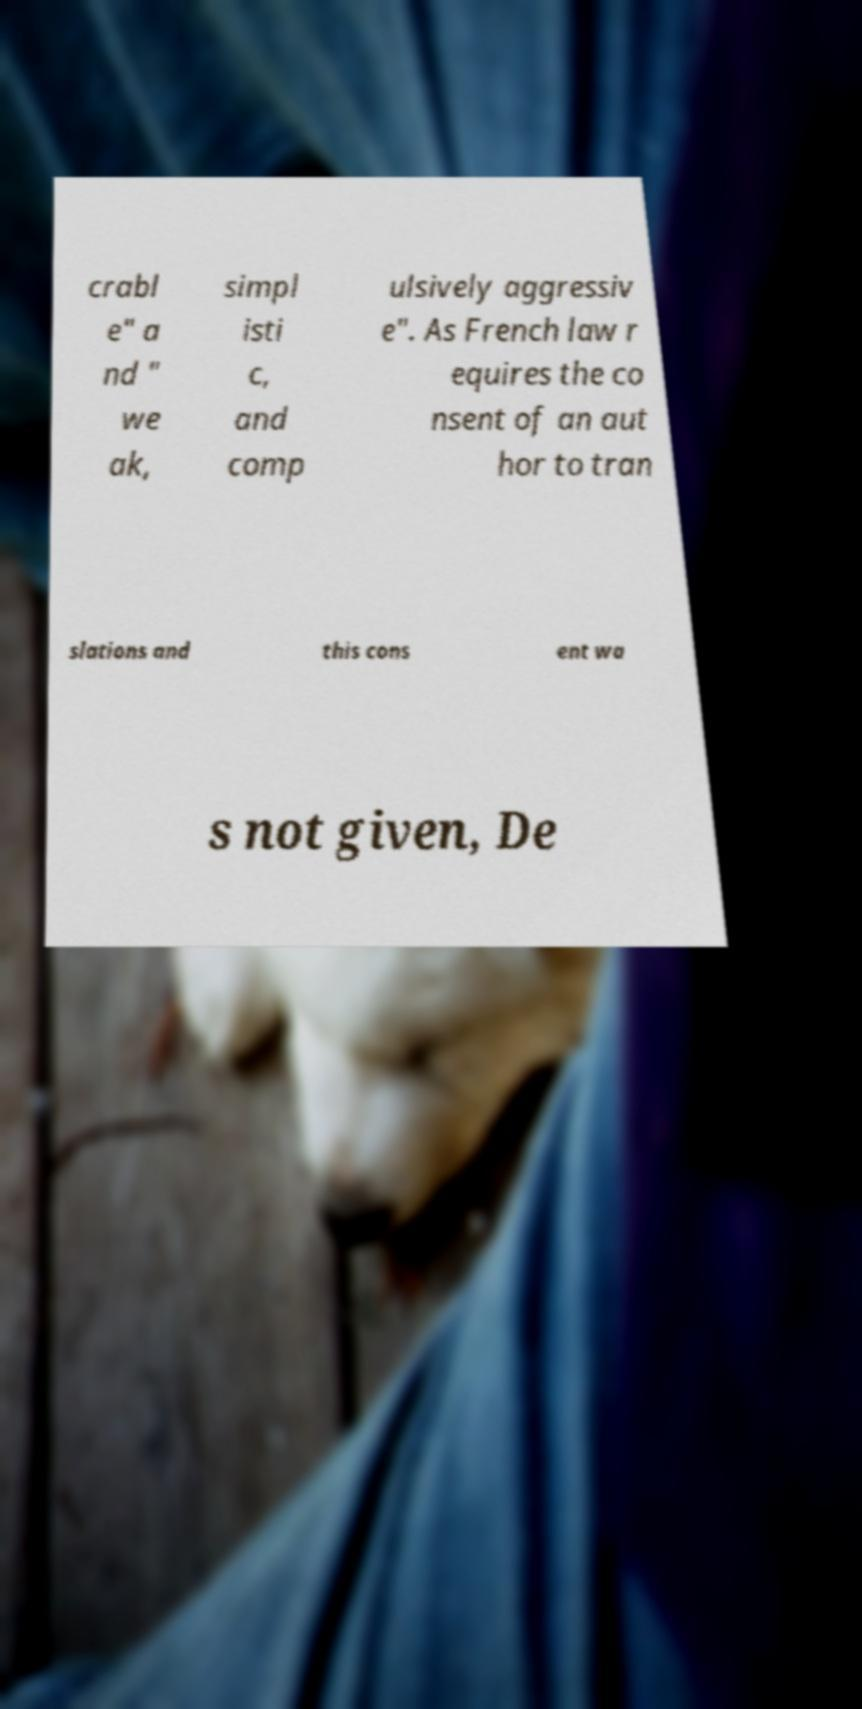Can you accurately transcribe the text from the provided image for me? crabl e" a nd " we ak, simpl isti c, and comp ulsively aggressiv e". As French law r equires the co nsent of an aut hor to tran slations and this cons ent wa s not given, De 